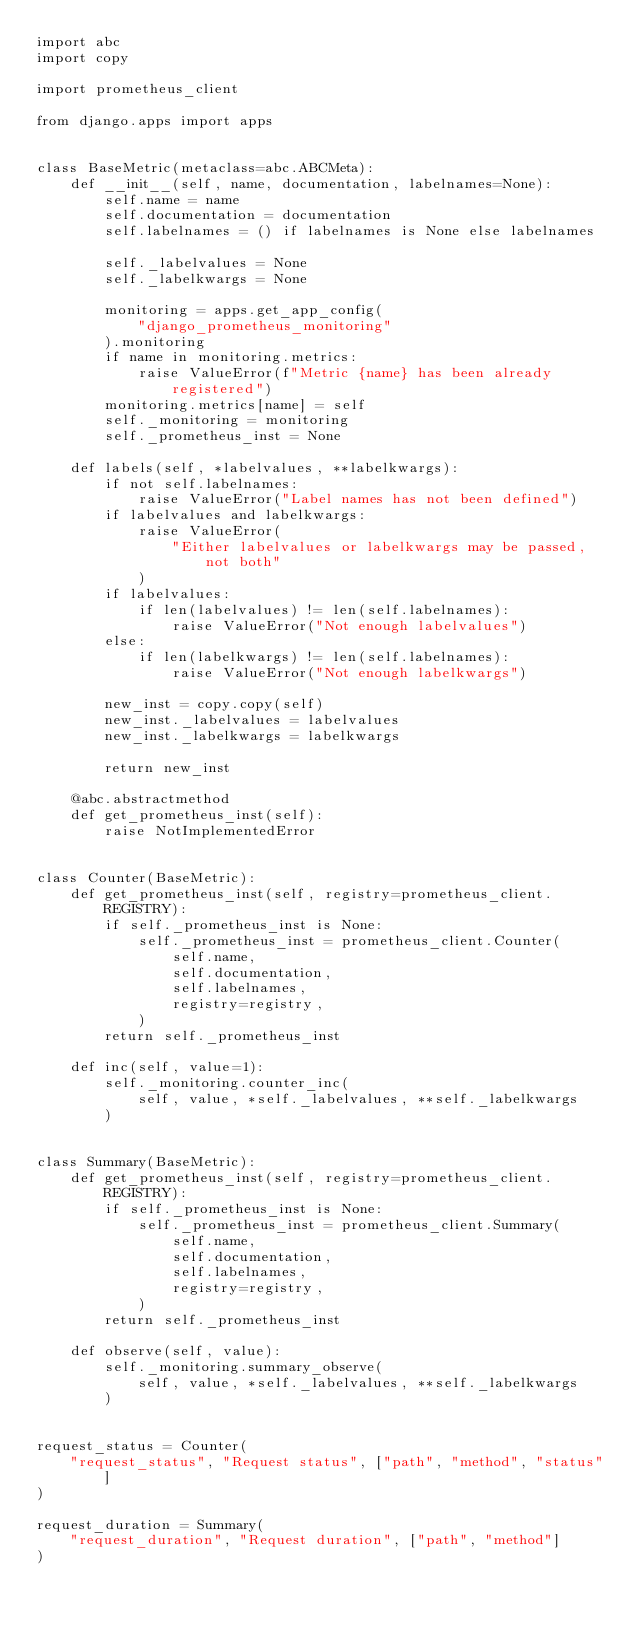<code> <loc_0><loc_0><loc_500><loc_500><_Python_>import abc
import copy

import prometheus_client

from django.apps import apps


class BaseMetric(metaclass=abc.ABCMeta):
    def __init__(self, name, documentation, labelnames=None):
        self.name = name
        self.documentation = documentation
        self.labelnames = () if labelnames is None else labelnames

        self._labelvalues = None
        self._labelkwargs = None

        monitoring = apps.get_app_config(
            "django_prometheus_monitoring"
        ).monitoring
        if name in monitoring.metrics:
            raise ValueError(f"Metric {name} has been already registered")
        monitoring.metrics[name] = self
        self._monitoring = monitoring
        self._prometheus_inst = None

    def labels(self, *labelvalues, **labelkwargs):
        if not self.labelnames:
            raise ValueError("Label names has not been defined")
        if labelvalues and labelkwargs:
            raise ValueError(
                "Either labelvalues or labelkwargs may be passed, not both"
            )
        if labelvalues:
            if len(labelvalues) != len(self.labelnames):
                raise ValueError("Not enough labelvalues")
        else:
            if len(labelkwargs) != len(self.labelnames):
                raise ValueError("Not enough labelkwargs")

        new_inst = copy.copy(self)
        new_inst._labelvalues = labelvalues
        new_inst._labelkwargs = labelkwargs

        return new_inst

    @abc.abstractmethod
    def get_prometheus_inst(self):
        raise NotImplementedError


class Counter(BaseMetric):
    def get_prometheus_inst(self, registry=prometheus_client.REGISTRY):
        if self._prometheus_inst is None:
            self._prometheus_inst = prometheus_client.Counter(
                self.name,
                self.documentation,
                self.labelnames,
                registry=registry,
            )
        return self._prometheus_inst

    def inc(self, value=1):
        self._monitoring.counter_inc(
            self, value, *self._labelvalues, **self._labelkwargs
        )


class Summary(BaseMetric):
    def get_prometheus_inst(self, registry=prometheus_client.REGISTRY):
        if self._prometheus_inst is None:
            self._prometheus_inst = prometheus_client.Summary(
                self.name,
                self.documentation,
                self.labelnames,
                registry=registry,
            )
        return self._prometheus_inst

    def observe(self, value):
        self._monitoring.summary_observe(
            self, value, *self._labelvalues, **self._labelkwargs
        )


request_status = Counter(
    "request_status", "Request status", ["path", "method", "status"]
)

request_duration = Summary(
    "request_duration", "Request duration", ["path", "method"]
)
</code> 